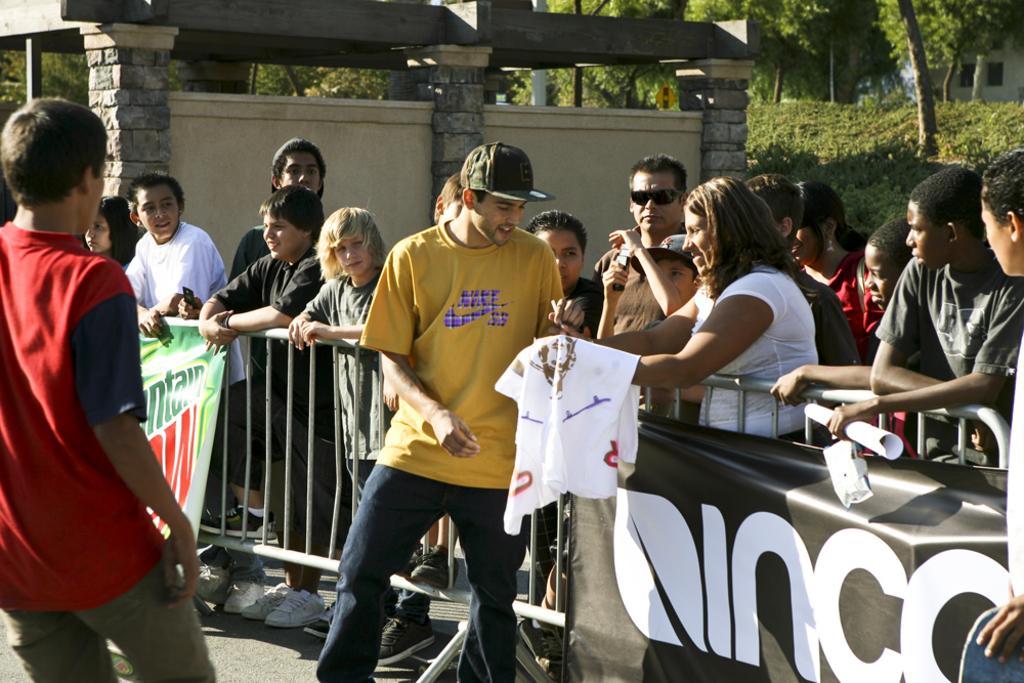Can you describe this image briefly? On the left side, there is a person in red color t-shirt, walking on the ground in front of a person who is in yellow color t-shirt, standing, near a fencing. Outside the fencing, there is a woman in white color t-shirt, holding a white color cloth and smiling. In the background, there are other persons standing, near wall of the building, there are plants and trees. 